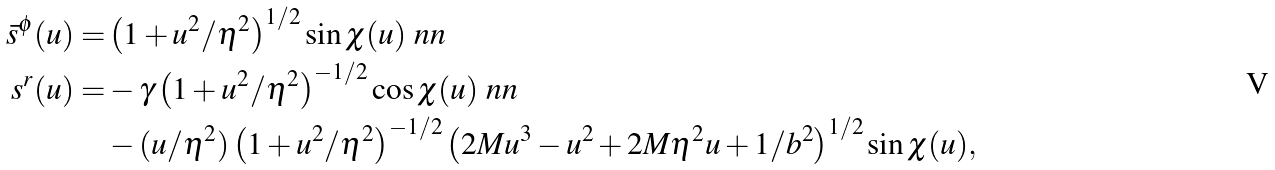Convert formula to latex. <formula><loc_0><loc_0><loc_500><loc_500>\bar { s } ^ { \phi } ( u ) = & \left ( 1 + u ^ { 2 } / \eta ^ { 2 } \right ) ^ { 1 / 2 } \sin \chi ( u ) \ n n \\ s ^ { r } ( u ) = & - \gamma \left ( 1 + u ^ { 2 } / \eta ^ { 2 } \right ) ^ { - 1 / 2 } \cos \chi ( u ) \ n n \\ & - ( u / \eta ^ { 2 } ) \left ( 1 + u ^ { 2 } / \eta ^ { 2 } \right ) ^ { - 1 / 2 } \left ( 2 M u ^ { 3 } - u ^ { 2 } + 2 M \eta ^ { 2 } u + 1 / b ^ { 2 } \right ) ^ { 1 / 2 } \sin \chi ( u ) ,</formula> 